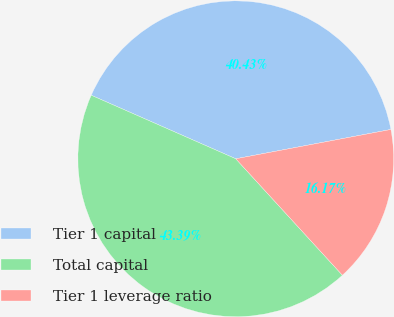<chart> <loc_0><loc_0><loc_500><loc_500><pie_chart><fcel>Tier 1 capital<fcel>Total capital<fcel>Tier 1 leverage ratio<nl><fcel>40.43%<fcel>43.39%<fcel>16.17%<nl></chart> 